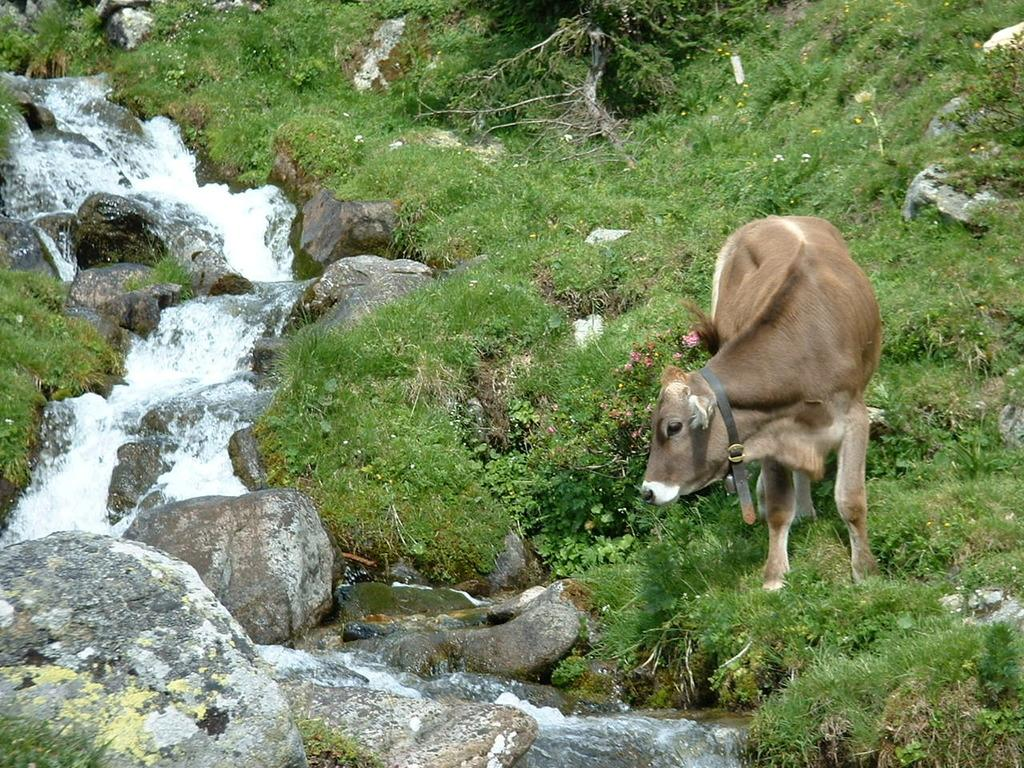What animal can be seen on the right side of the image? There is a cow on the right side of the image. What is happening on the left side of the image? There is a water flow on the left side of the image. How does the water flow in the image? The water flows between stones in the image. What type of vegetation is present on the ground in the image? There are plants on the ground in the image. What type of material is present on the ground in the image? There are stones on the ground in the image. What month is depicted in the image? The image does not depict a specific month; it shows a cow, water flow, plants, and stones. What hope can be seen in the image? There is no specific hope depicted in the image; it is a scene of a cow, water flow, plants, and stones. 